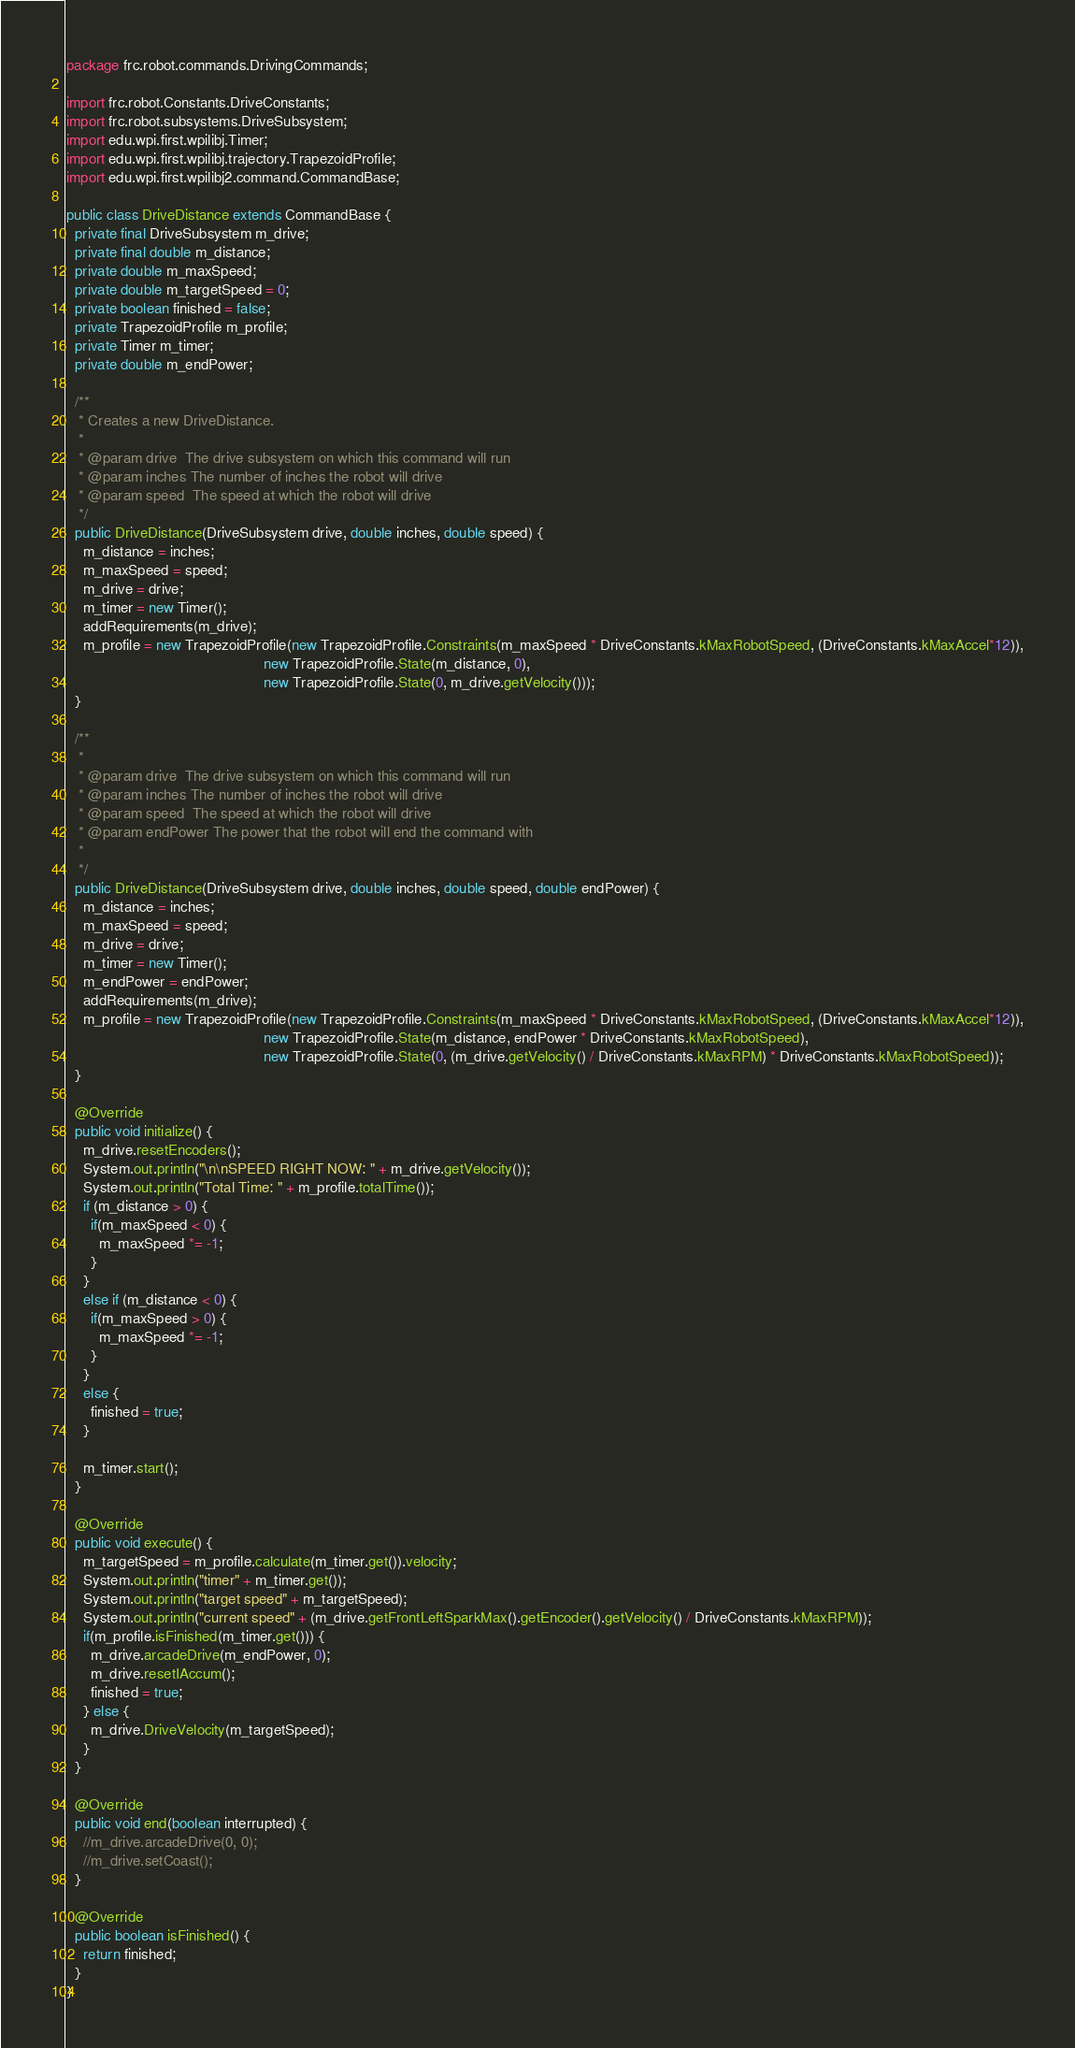<code> <loc_0><loc_0><loc_500><loc_500><_Java_>package frc.robot.commands.DrivingCommands;

import frc.robot.Constants.DriveConstants;
import frc.robot.subsystems.DriveSubsystem;
import edu.wpi.first.wpilibj.Timer;
import edu.wpi.first.wpilibj.trajectory.TrapezoidProfile;
import edu.wpi.first.wpilibj2.command.CommandBase;

public class DriveDistance extends CommandBase {
  private final DriveSubsystem m_drive;
  private final double m_distance;
  private double m_maxSpeed;
  private double m_targetSpeed = 0;
  private boolean finished = false;
  private TrapezoidProfile m_profile;
  private Timer m_timer;
  private double m_endPower;

  /**
   * Creates a new DriveDistance.
   *
   * @param drive  The drive subsystem on which this command will run
   * @param inches The number of inches the robot will drive
   * @param speed  The speed at which the robot will drive
   */
  public DriveDistance(DriveSubsystem drive, double inches, double speed) {
    m_distance = inches;
    m_maxSpeed = speed;
    m_drive = drive;
    m_timer = new Timer();
    addRequirements(m_drive);
    m_profile = new TrapezoidProfile(new TrapezoidProfile.Constraints(m_maxSpeed * DriveConstants.kMaxRobotSpeed, (DriveConstants.kMaxAccel*12)),
                                                new TrapezoidProfile.State(m_distance, 0),
                                                new TrapezoidProfile.State(0, m_drive.getVelocity()));
  }

  /**
   * 
   * @param drive  The drive subsystem on which this command will run
   * @param inches The number of inches the robot will drive
   * @param speed  The speed at which the robot will drive
   * @param endPower The power that the robot will end the command with
   * 
   */
  public DriveDistance(DriveSubsystem drive, double inches, double speed, double endPower) {
    m_distance = inches;
    m_maxSpeed = speed;
    m_drive = drive;
    m_timer = new Timer();
    m_endPower = endPower;
    addRequirements(m_drive);
    m_profile = new TrapezoidProfile(new TrapezoidProfile.Constraints(m_maxSpeed * DriveConstants.kMaxRobotSpeed, (DriveConstants.kMaxAccel*12)),
                                                new TrapezoidProfile.State(m_distance, endPower * DriveConstants.kMaxRobotSpeed),
                                                new TrapezoidProfile.State(0, (m_drive.getVelocity() / DriveConstants.kMaxRPM) * DriveConstants.kMaxRobotSpeed));
  }

  @Override
  public void initialize() {
    m_drive.resetEncoders();
    System.out.println("\n\nSPEED RIGHT NOW: " + m_drive.getVelocity());
    System.out.println("Total Time: " + m_profile.totalTime());
    if (m_distance > 0) {
      if(m_maxSpeed < 0) {
        m_maxSpeed *= -1;
      }
    }
    else if (m_distance < 0) {
      if(m_maxSpeed > 0) {
        m_maxSpeed *= -1;
      }
    }
    else {
      finished = true;
    }

    m_timer.start();
  }

  @Override
  public void execute() {
    m_targetSpeed = m_profile.calculate(m_timer.get()).velocity;
    System.out.println("timer" + m_timer.get());
    System.out.println("target speed" + m_targetSpeed);
    System.out.println("current speed" + (m_drive.getFrontLeftSparkMax().getEncoder().getVelocity() / DriveConstants.kMaxRPM));
    if(m_profile.isFinished(m_timer.get())) {
      m_drive.arcadeDrive(m_endPower, 0);
      m_drive.resetIAccum();
      finished = true;
    } else {
      m_drive.DriveVelocity(m_targetSpeed);
    }
  }

  @Override
  public void end(boolean interrupted) {
    //m_drive.arcadeDrive(0, 0);
    //m_drive.setCoast();
  }

  @Override
  public boolean isFinished() {
    return finished;
  }
}</code> 